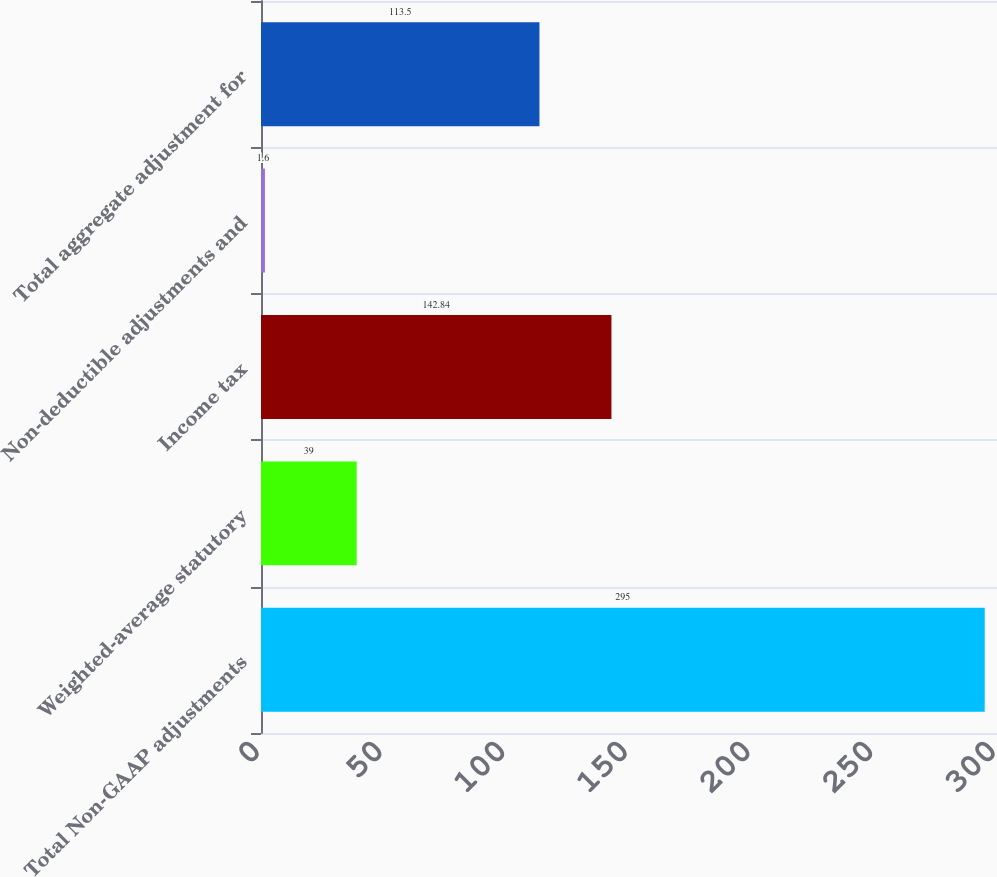Convert chart. <chart><loc_0><loc_0><loc_500><loc_500><bar_chart><fcel>Total Non-GAAP adjustments<fcel>Weighted-average statutory<fcel>Income tax<fcel>Non-deductible adjustments and<fcel>Total aggregate adjustment for<nl><fcel>295<fcel>39<fcel>142.84<fcel>1.6<fcel>113.5<nl></chart> 